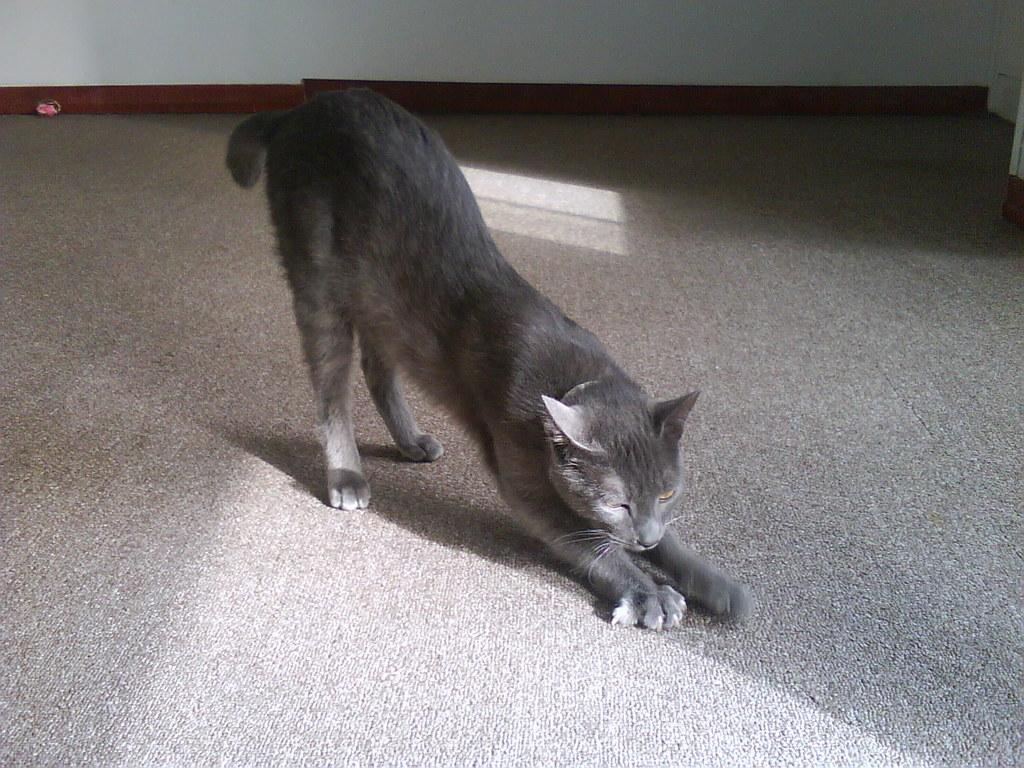What type of animal is in the image? There is a cat in the image. Where is the cat located? The cat is on the ground. What can be seen in the background of the image? There is a wall and objects visible in the background of the image. What type of grip does the cat have on the board in the image? There is no board present in the image, and the cat is not holding anything. 